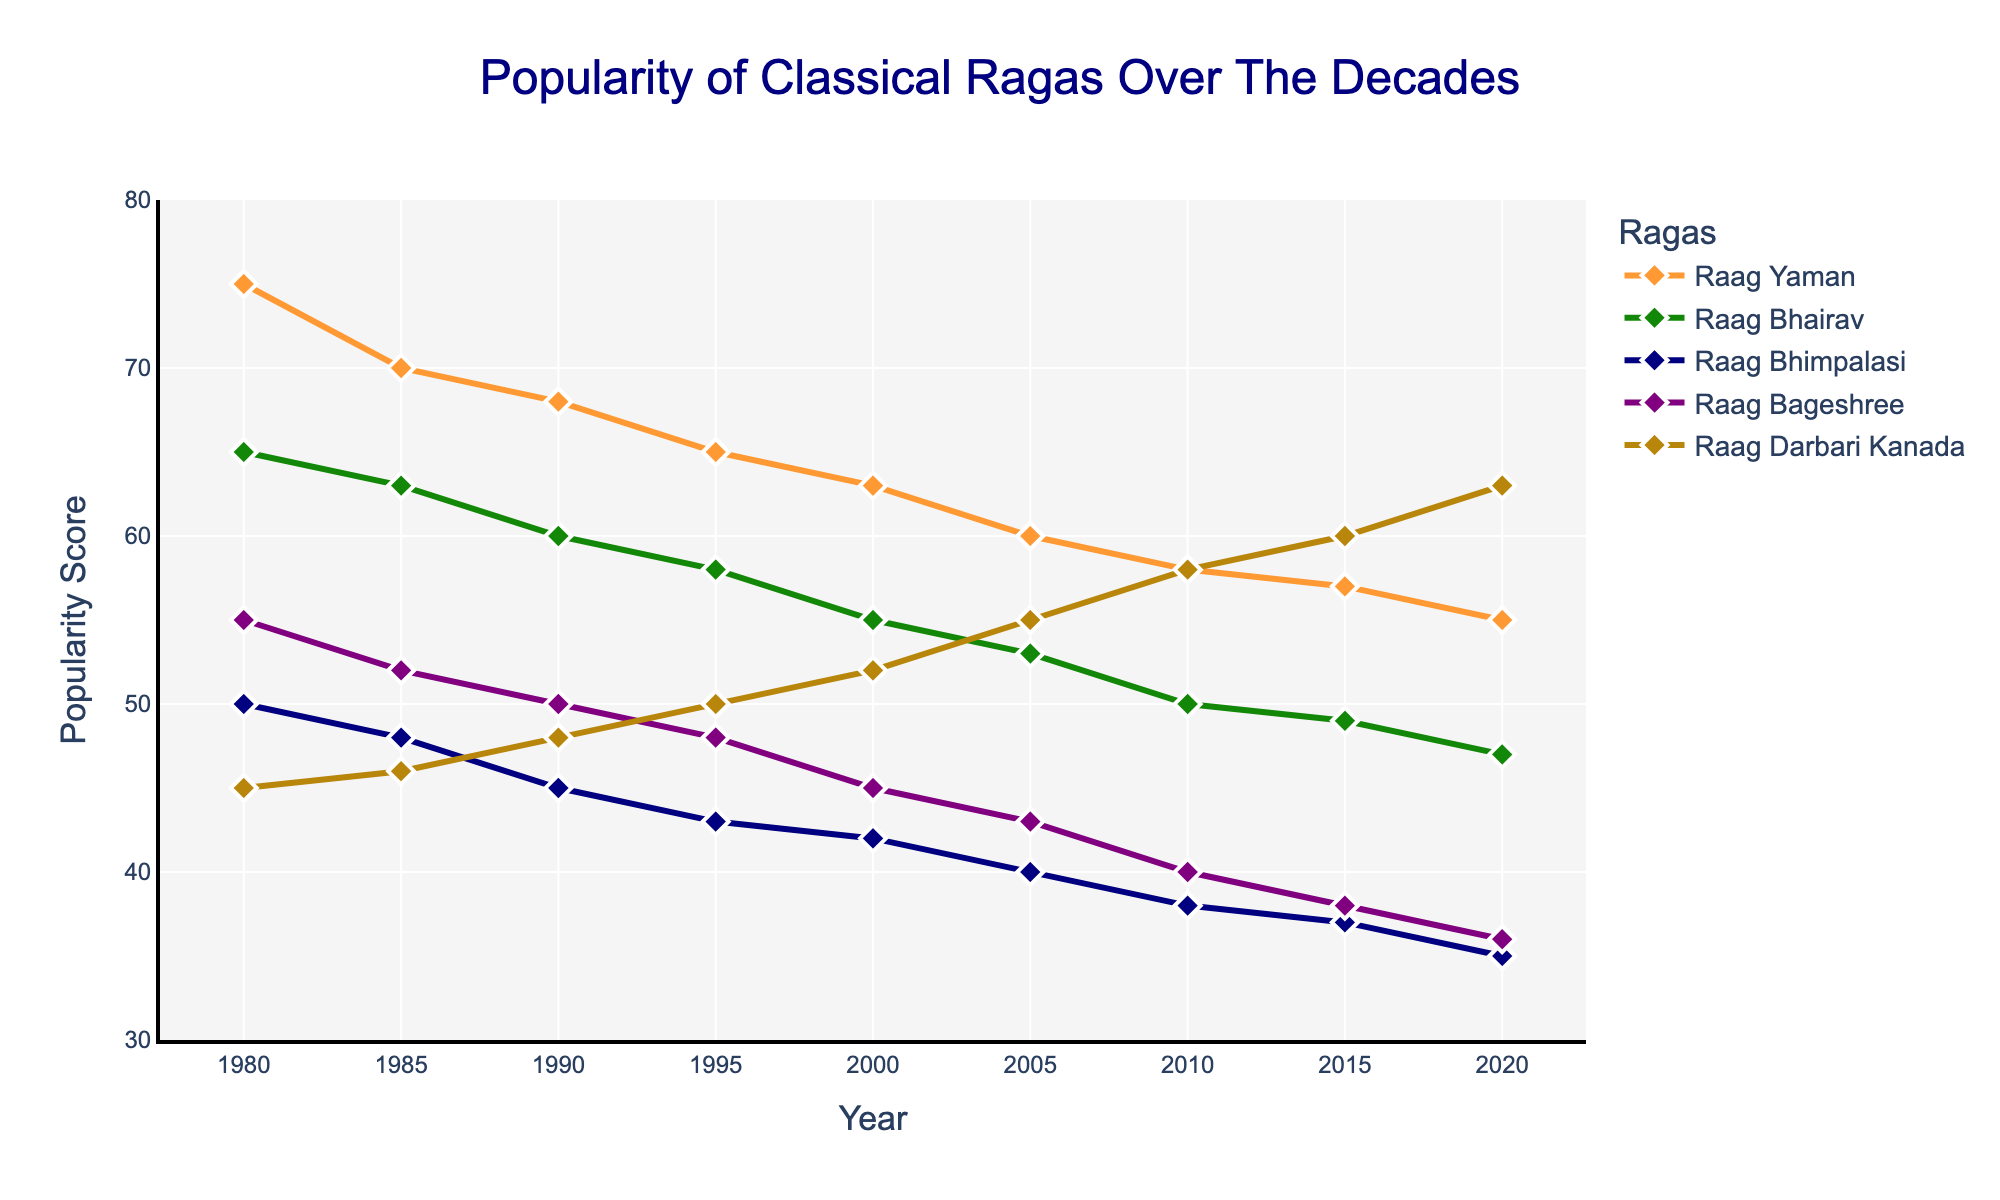What is the title of the plot? The title of the plot is located at the top. It reads "Popularity of Classical Ragas Over The Decades."
Answer: Popularity of Classical Ragas Over The Decades What is the color of the line representing Raag Bageshree? The color of the line can be identified by looking at the legend. The line for Raag Bageshree is represented in purple.
Answer: Purple How many ragas are depicted in the plot? There are different colored lines in the plot, each representing a raga. By counting them, we see five ragas in total.
Answer: 5 Which raga had the highest popularity score in 2020? By examining the y-values in 2020, Raag Darbari Kanada has the highest point on the y-axis.
Answer: Raag Darbari Kanada What is the trend of Raag Yaman's popularity over the years? By observing Raag Yaman's line from 1980 to 2020, the trend shows a gradual decline in popularity.
Answer: Declining Which raga has shown an increasing trend in popularity? By examining all the lines, only Raag Darbari Kanada shows an increasing trend in its popularity score.
Answer: Raag Darbari Kanada Was Raag Bhimpalasi ever the most popular raga at any point between 1980 to 2020? By comparing the lines, Raag Bhimpalasi never surpasses any other line in popularity through the given period.
Answer: No In what year did Raag Bhairav and Raag Bageshree have the same popularity score? By looking at the intersection points of Raag Bhairav and Raag Bageshree, in 1995, they both have a score of 48.
Answer: 1995 What is the difference in popularity scores between Raag Yaman and Raag Darbari Kanada in the year 2000? By finding the y-value for both in 2000, Raag Yaman is 63 and Raag Darbari Kanada is 52. The difference is 63 - 52 = 11.
Answer: 11 Which raga experienced the greatest decrease in popularity from 1980 to 2020? By comparing the start and end values of each raga’s line, Raag Bhimpalasi went from 50 to 35, a decrease of 15 points, which is the greatest among all.
Answer: Raag Bhimpalasi 